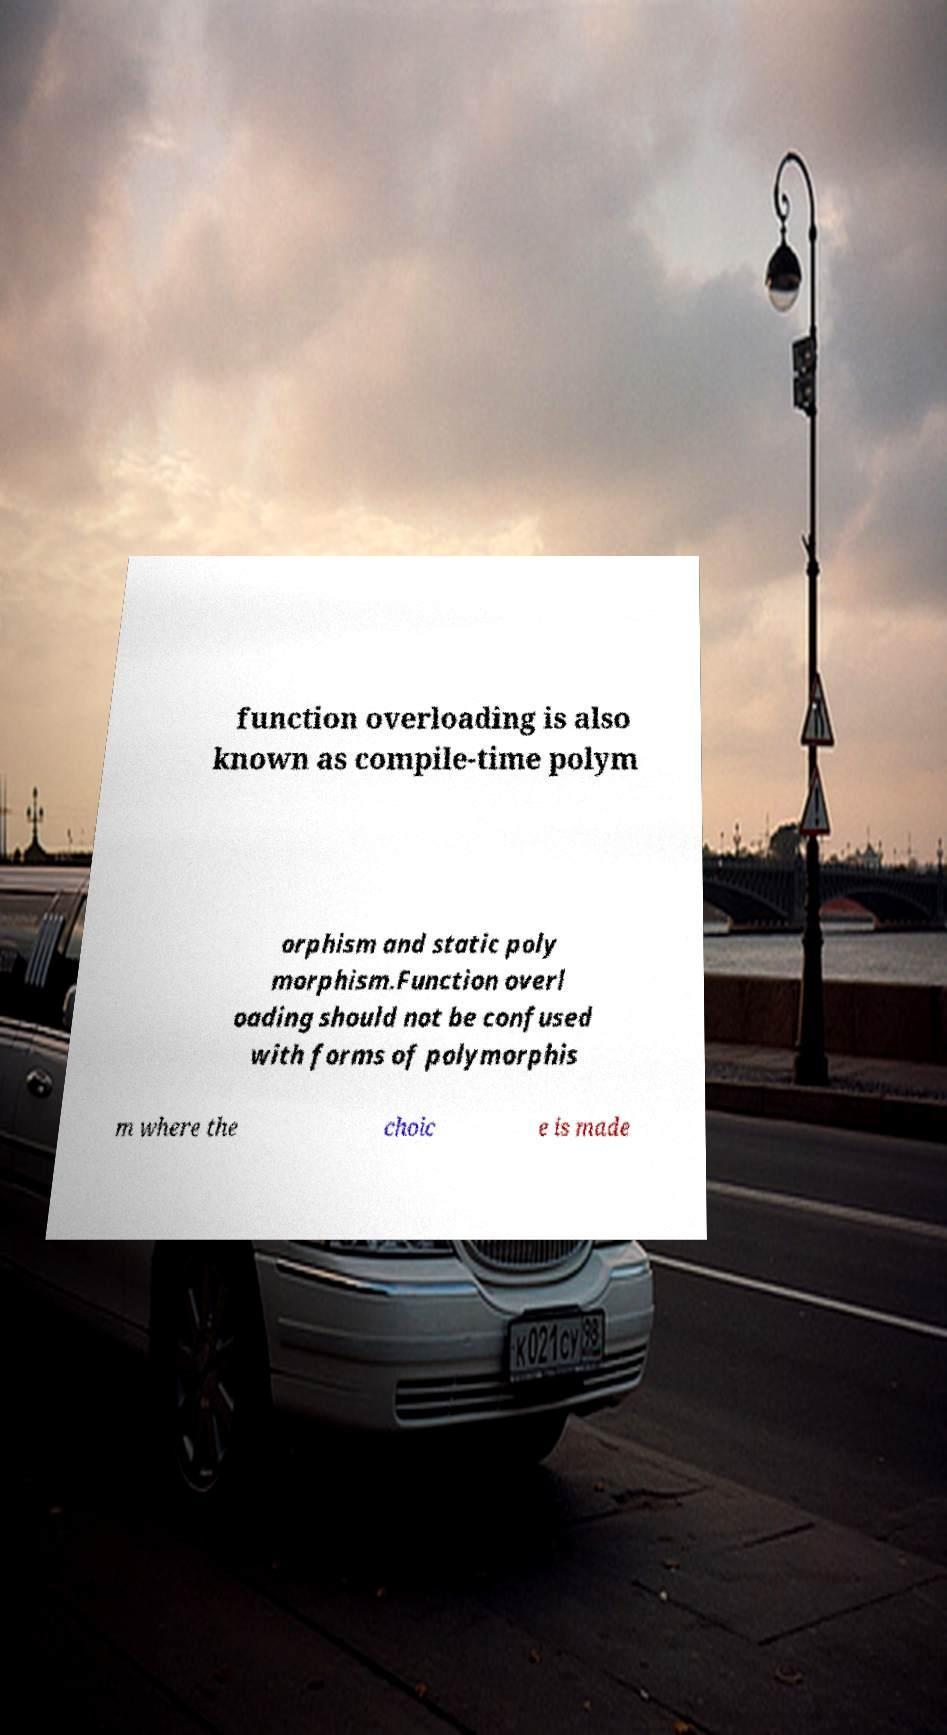Can you accurately transcribe the text from the provided image for me? function overloading is also known as compile-time polym orphism and static poly morphism.Function overl oading should not be confused with forms of polymorphis m where the choic e is made 